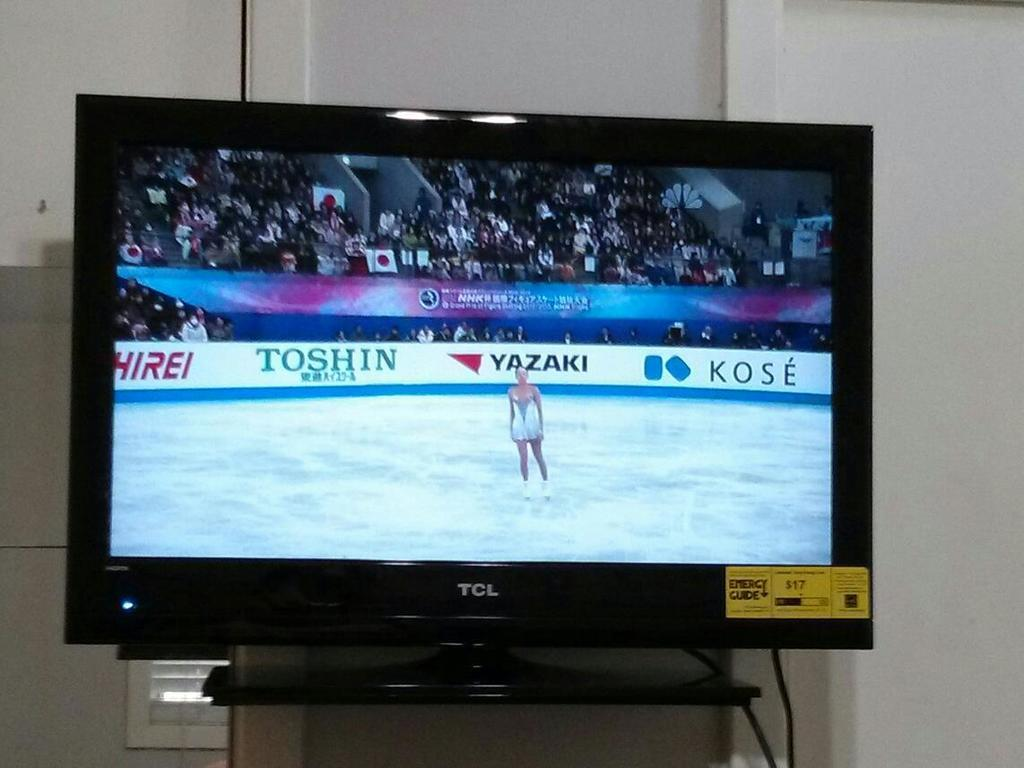<image>
Share a concise interpretation of the image provided. A TCL tv with ice skating being displayed. 